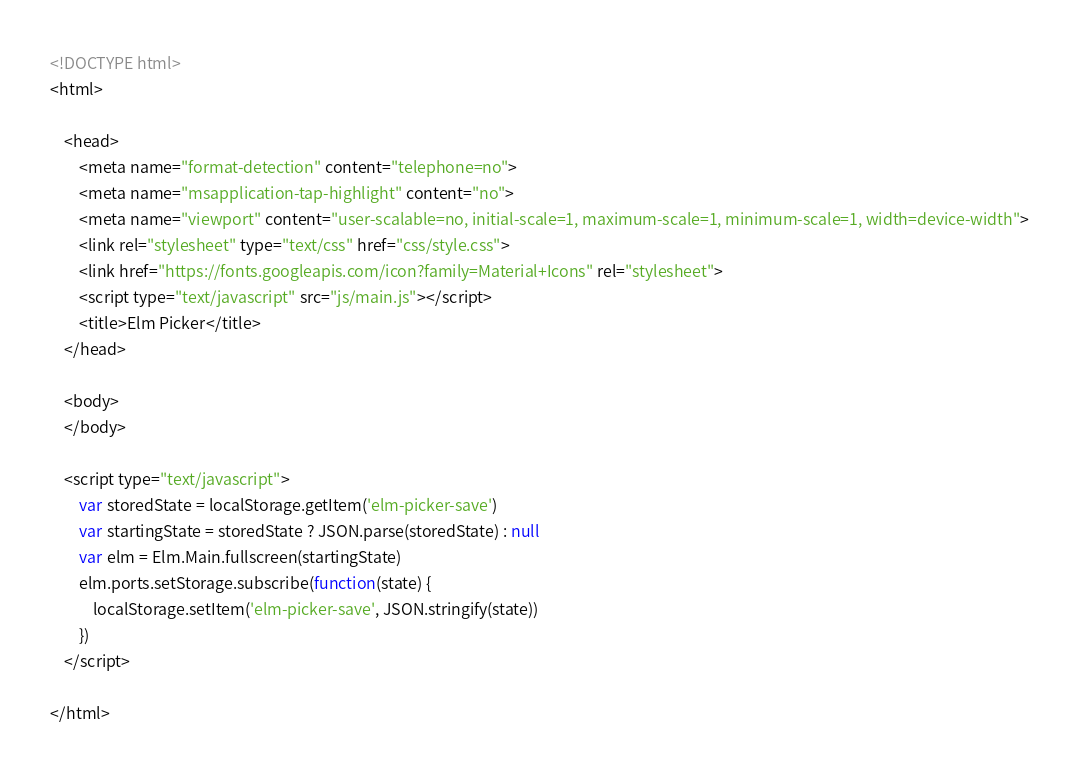<code> <loc_0><loc_0><loc_500><loc_500><_HTML_><!DOCTYPE html>
<html>

	<head>
		<meta name="format-detection" content="telephone=no">
		<meta name="msapplication-tap-highlight" content="no">
		<meta name="viewport" content="user-scalable=no, initial-scale=1, maximum-scale=1, minimum-scale=1, width=device-width">
		<link rel="stylesheet" type="text/css" href="css/style.css">
		<link href="https://fonts.googleapis.com/icon?family=Material+Icons" rel="stylesheet">
		<script type="text/javascript" src="js/main.js"></script>
		<title>Elm Picker</title>
	</head>

	<body>
	</body>

	<script type="text/javascript">
        var storedState = localStorage.getItem('elm-picker-save')
        var startingState = storedState ? JSON.parse(storedState) : null
        var elm = Elm.Main.fullscreen(startingState)
        elm.ports.setStorage.subscribe(function(state) {
            localStorage.setItem('elm-picker-save', JSON.stringify(state))
        })
    </script>

</html>
</code> 